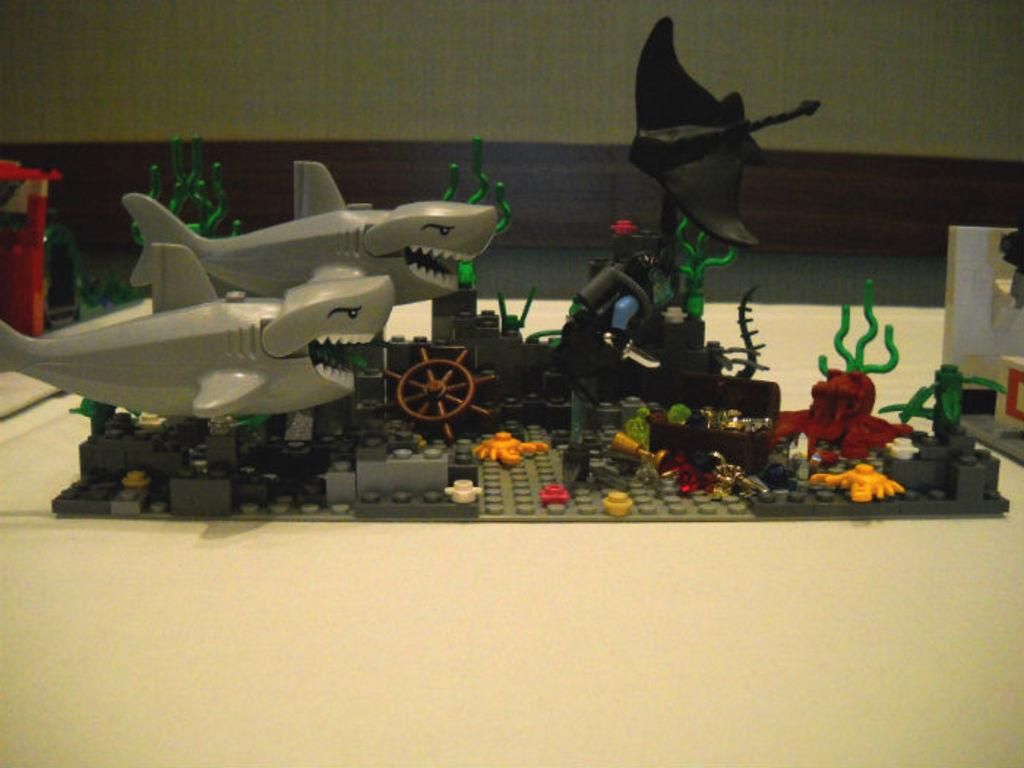What is the main subject of the image? The main subject of the image is a miniature. What else can be seen in the image besides the miniature? There are toys in the image. Where are the miniature and toys located? The miniature and toys are on a desk. What can be seen in the background of the image? There is a wall visible in the background of the image. What type of question is being asked in the image? There is no question being asked in the image; it features a miniature and toys on a desk. What substance is being sold in the shop depicted in the image? There is no shop depicted in the image; it only shows a miniature and toys on a desk. 